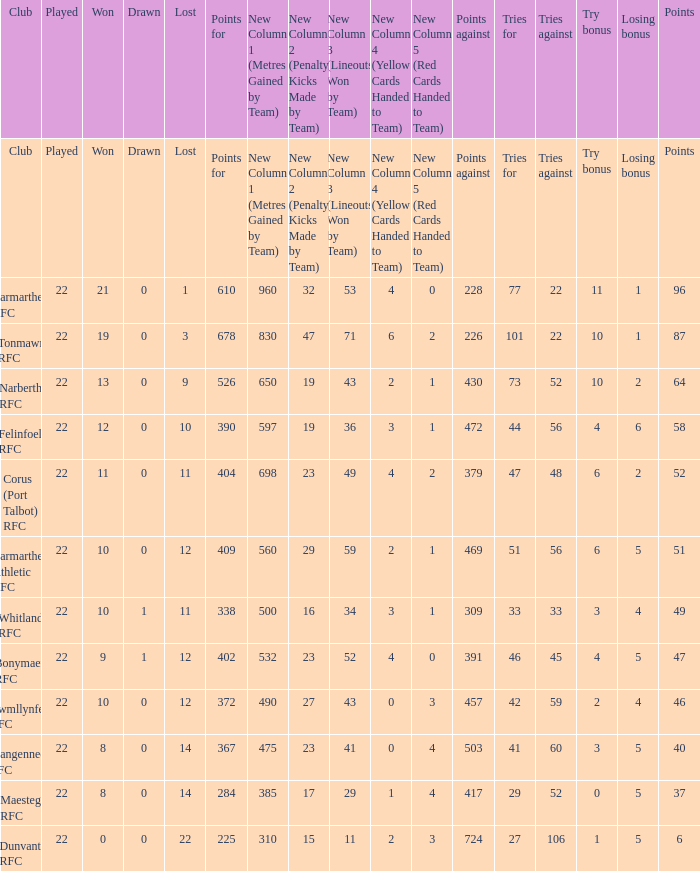Name the tries against for 87 points 22.0. 